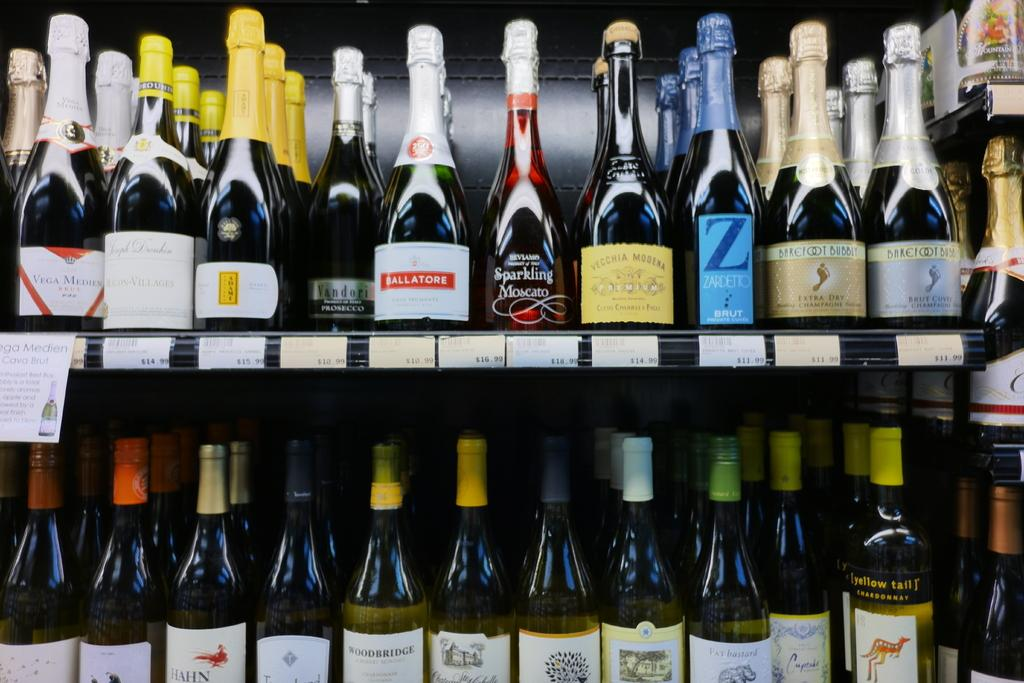<image>
Offer a succinct explanation of the picture presented. Store with a row selling alcohol including a bottle that says Z. 